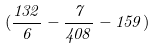Convert formula to latex. <formula><loc_0><loc_0><loc_500><loc_500>( \frac { 1 3 2 } { 6 } - \frac { 7 } { 4 0 8 } - 1 5 9 )</formula> 